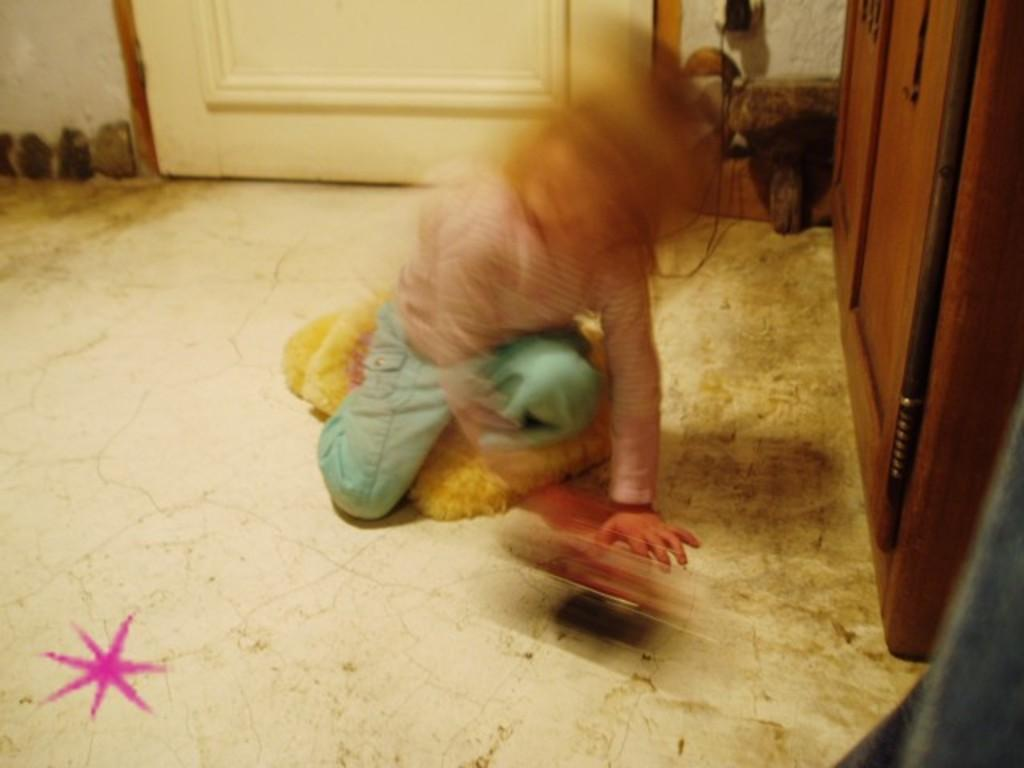What is the main subject in the image? There is a kid in the image. What can be seen in the background of the image? There is a door and a wall in the image. Are there any furniture or storage items in the image? Yes, there is a wooden shelf in the image. What is the surface that the kid and other objects are standing on? The floor is visible in the image. What type of cushion is placed on the clover in the image? There is no cushion or clover present in the image. What type of shop can be seen in the background of the image? There is no shop visible in the image; it features a kid, a door, a wall, a wooden shelf, and a floor. 